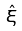<formula> <loc_0><loc_0><loc_500><loc_500>\hat { \xi }</formula> 